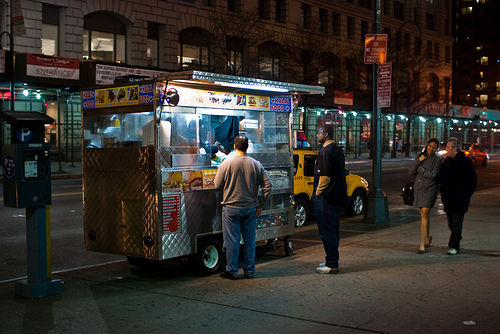<image>
Is there a man behind the man? No. The man is not behind the man. From this viewpoint, the man appears to be positioned elsewhere in the scene. 